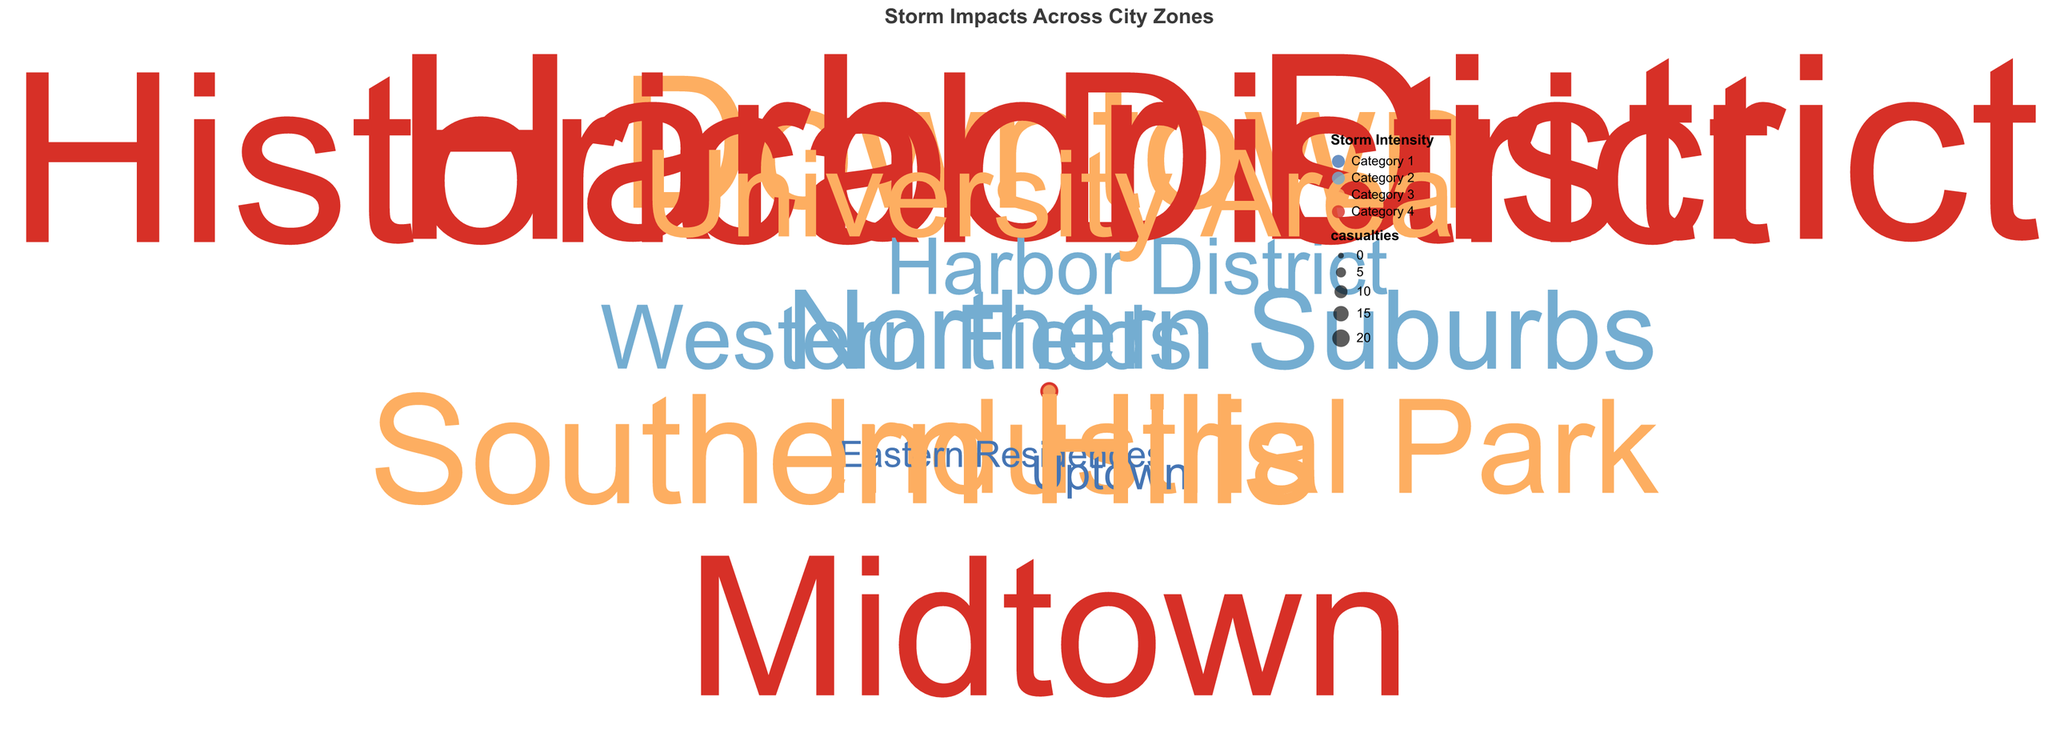What is the title of the figure? The title is generally found at the top of the chart. It provides a summary of what the chart depicts.
Answer: Storm Impacts Across City Zones Which zone experienced the highest number of casualties from Category 4 storms? By looking at the color-coded data points with the highest radius (biggest size) in the red color, which represents Category 4 storms, we see that the Harbor District has the largest point.
Answer: Harbor District How many zones experienced storms of Category 3 intensity? Count the distinct points colored with orange, representing Category 3 storms. These zones are Downtown, Industrial Park, Southern Hills, and University Area.
Answer: 4 zones Which two zones have the lowest number of casualties? Identify the smallest points on the chart. These points are in the Eastern Residences and Uptown.
Answer: Eastern Residences and Uptown What is the average number of casualties for Category 2 storms across the zones? Identify all Category 2 points (light blue). Their casualties are 8, 5, and 6. Sum these values and divide by the number of points: (8 + 5 + 6) / 3 = 19 / 3.
Answer: 6.33 Compare the casualties in the Historical District and Midtown for Category 4 storms. Which one is higher? Compare the size of the red points in Historical District and Midtown. Historical District has 20 casualties, and Midtown has 16.
Answer: Historical District What is the total number of casualties in zones impacted by Category 4 storms? Sum the casualties for all Category 4 zones: 22 (Harbor District) + 16 (Midtown) + 20 (Historical District) = 58.
Answer: 58 Which zone has the highest number of casualties impacted by Category 3 storms? Look at the orange-colored points and find the one with the largest size. This point is Downtown with 15 casualties.
Answer: Downtown How many categories of storm intensity are represented in the chart? Identify the distinct colors used for representing storm intensities. The chart shows four colors, each representing a different category.
Answer: 4 Compare the casualties in the Downtown zone to the Southern Hills zone for Category 3 storms. Which zone has more casualties? Both Downtown and Southern Hills have Category 3 storms, and comparing the casualties, Downtown has 15, and Southern Hills has 12.
Answer: Downtown 